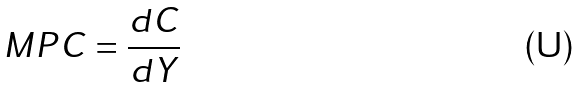<formula> <loc_0><loc_0><loc_500><loc_500>M P C = \frac { d C } { d Y }</formula> 